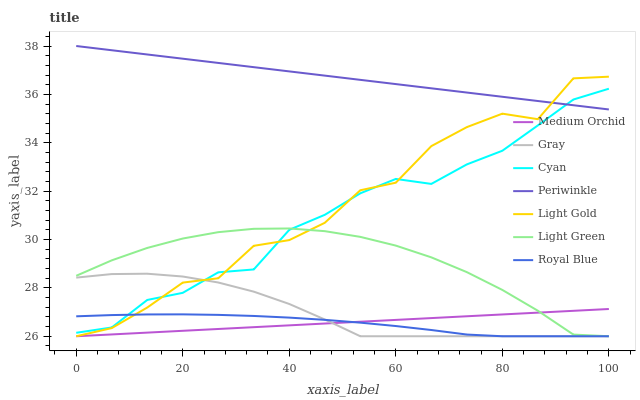Does Royal Blue have the minimum area under the curve?
Answer yes or no. Yes. Does Periwinkle have the maximum area under the curve?
Answer yes or no. Yes. Does Medium Orchid have the minimum area under the curve?
Answer yes or no. No. Does Medium Orchid have the maximum area under the curve?
Answer yes or no. No. Is Periwinkle the smoothest?
Answer yes or no. Yes. Is Light Gold the roughest?
Answer yes or no. Yes. Is Medium Orchid the smoothest?
Answer yes or no. No. Is Medium Orchid the roughest?
Answer yes or no. No. Does Gray have the lowest value?
Answer yes or no. Yes. Does Periwinkle have the lowest value?
Answer yes or no. No. Does Periwinkle have the highest value?
Answer yes or no. Yes. Does Medium Orchid have the highest value?
Answer yes or no. No. Is Medium Orchid less than Cyan?
Answer yes or no. Yes. Is Periwinkle greater than Light Green?
Answer yes or no. Yes. Does Cyan intersect Gray?
Answer yes or no. Yes. Is Cyan less than Gray?
Answer yes or no. No. Is Cyan greater than Gray?
Answer yes or no. No. Does Medium Orchid intersect Cyan?
Answer yes or no. No. 